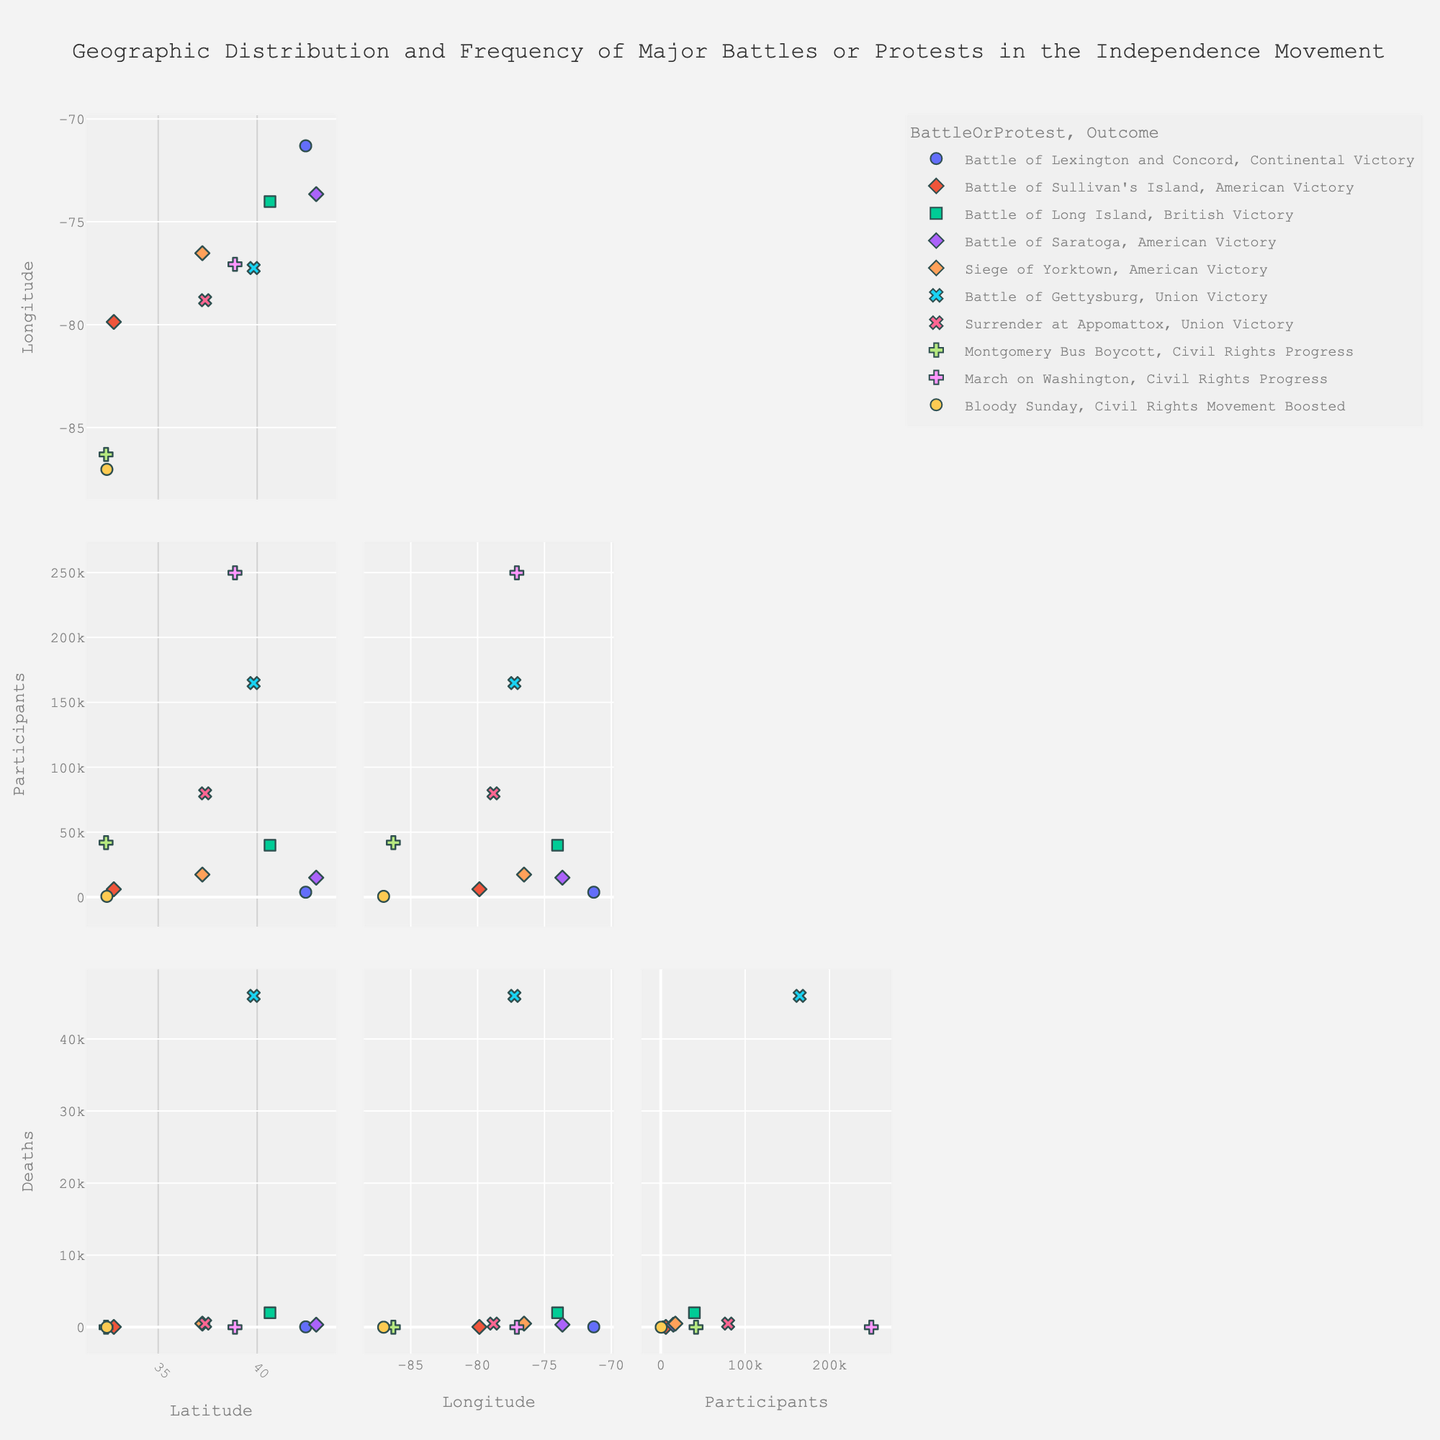What is the title of the Scatter Plot Matrix (SPLOM)? The title of the Scatter Plot Matrix (SPLOM) is usually displayed at the top of the plot. Here, it specifically indicates the subject of the data, "Geographic Distribution and Frequency of Major Battles or Protests in the Independence Movement."
Answer: Geographic Distribution and Frequency of Major Battles or Protests in the Independence Movement How many battle or protest events are represented in the Scatter Plot Matrix? Each point in the SPLOM represents a single battle or protest event. By counting the total number of points, you can find the number of events.
Answer: 10 Which battle or protest event had the highest number of participants? By identifying the point that represents the largest value on the Participants axis, you can determine which event had the highest participation. The tooltips of the points can help verify the event name.
Answer: Battle of Gettysburg What is the difference in participant numbers between the Battle of Long Island and the Battle of Saratoga? The participant numbers for the Battle of Long Island and the Battle of Saratoga can be found by locating these points on the dimension representing "Participants" and deducting the number for the Battle of Saratoga from the Battle of Long Island.
Answer: 25,000 How does the latitude of the March on Washington compare to that of the Siege of Yorktown? By checking the vertical position of the points corresponding to these events on the Latitude dimension, you can compare the latitudes. The March on Washington in D.C. (38.8893) is north of the Siege of Yorktown in Virginia (37.2388).
Answer: March on Washington is north of Siege of Yorktown Is there a correlation between the number of participants and the outcome of battles/protests seen in the SPLOM? By color-coding or symbolizing the points by outcome and examining the trend within the Participants dimension, you can observe if certain outcomes correspond to higher or lower participant numbers more frequently.
Answer: Yes, battles with significant outcomes tend to have more participants Which event resulted in the highest number of deaths? To determine which event had the most fatalities, locate the point with the highest value on the Deaths dimension. The tooltip will help identify the corresponding event.
Answer: Battle of Gettysburg Compare the geographic distribution of battles to protests in the SPLOM. What regions show higher concentration for battles vs. protests? By examining the Latitude and Longitude dimensions, you can identify clusters representing battles and protests and determine if there is a geographical pattern. Battles appear to be more concentrated in the northeastern regions, while protests are distributed differently.
Answer: Battles are more concentrated in the Northeast, protests vary What is the average number of participants in the Civil Rights protests compared to the Independent Movement battles? Calculate the average number of participants for each group (Civil Rights protests and Independence Movement battles) by summing the participants in each group and dividing by the number of events in each group.
Answer: Civil Rights protests: 97,866.67, Independence Movement battles: 30,300 